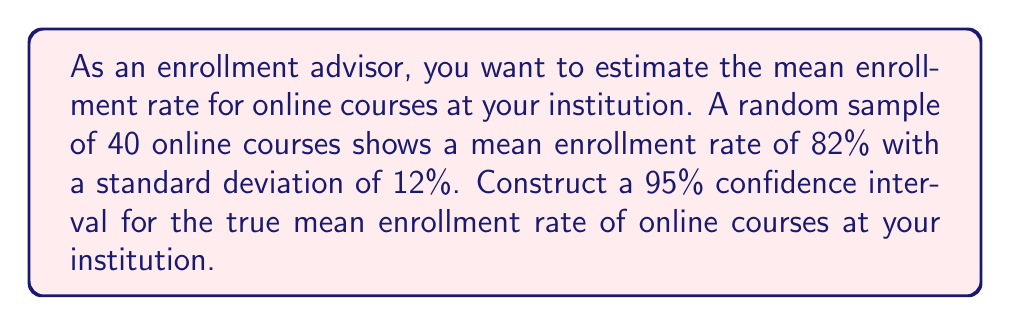Can you answer this question? To construct a confidence interval for the mean enrollment rate, we'll follow these steps:

1. Identify the given information:
   - Sample size: $n = 40$
   - Sample mean: $\bar{x} = 82\%$
   - Sample standard deviation: $s = 12\%$
   - Confidence level: 95% (α = 0.05)

2. Determine the critical value:
   For a 95% confidence interval with df = 39, we use the t-distribution.
   The critical value is $t_{0.025, 39} = 2.023$ (from t-table)

3. Calculate the standard error of the mean:
   $SE = \frac{s}{\sqrt{n}} = \frac{12}{\sqrt{40}} = 1.8974$

4. Calculate the margin of error:
   $ME = t_{0.025, 39} \times SE = 2.023 \times 1.8974 = 3.8385$

5. Construct the confidence interval:
   $CI = \bar{x} \pm ME$
   $CI = 82\% \pm 3.8385\%$
   $CI = (78.1615\%, 85.8385\%)$

Therefore, we are 95% confident that the true mean enrollment rate for online courses at the institution falls between 78.16% and 85.84%.
Answer: (78.16%, 85.84%) 